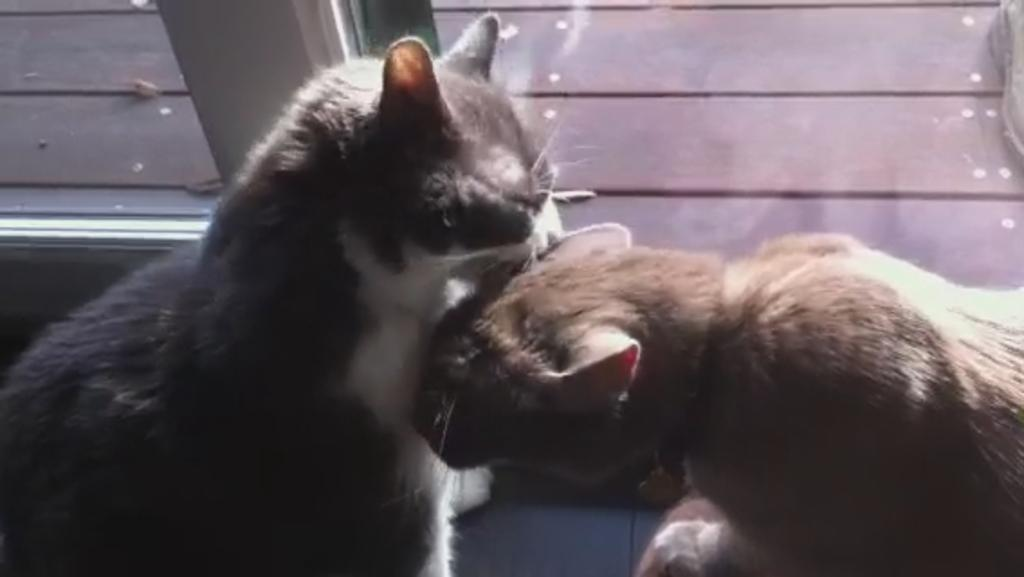How many cats are present in the image? There are two cats in the image. Can you describe the background of the image? There is a glass in the background of the image. Where is the nest located in the image? There is no nest present in the image. How many babies can be seen in the image? There are no babies present in the image. 